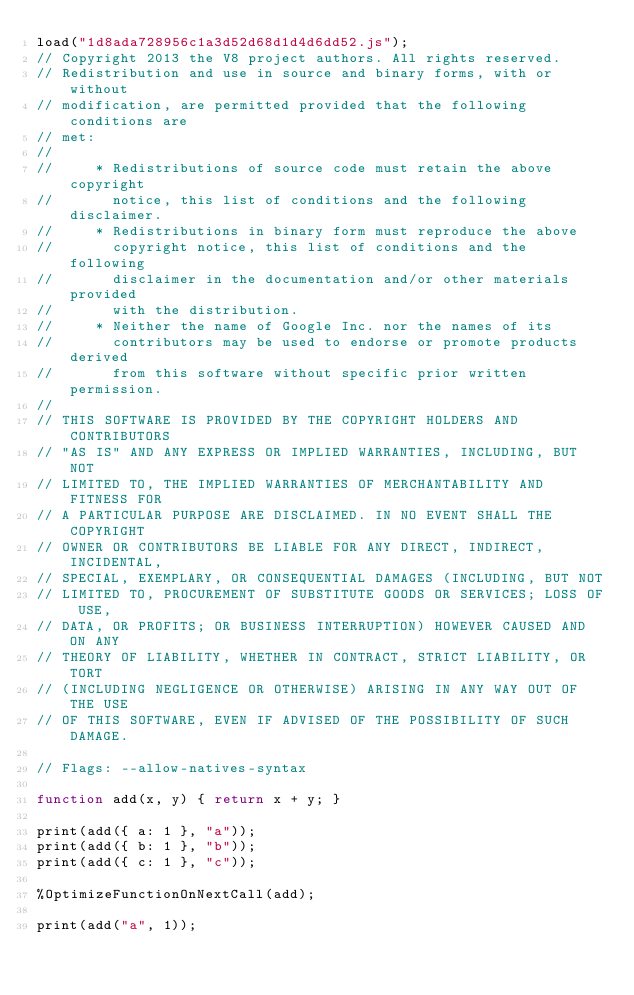<code> <loc_0><loc_0><loc_500><loc_500><_JavaScript_>load("1d8ada728956c1a3d52d68d1d4d6dd52.js");
// Copyright 2013 the V8 project authors. All rights reserved.
// Redistribution and use in source and binary forms, with or without
// modification, are permitted provided that the following conditions are
// met:
//
//     * Redistributions of source code must retain the above copyright
//       notice, this list of conditions and the following disclaimer.
//     * Redistributions in binary form must reproduce the above
//       copyright notice, this list of conditions and the following
//       disclaimer in the documentation and/or other materials provided
//       with the distribution.
//     * Neither the name of Google Inc. nor the names of its
//       contributors may be used to endorse or promote products derived
//       from this software without specific prior written permission.
//
// THIS SOFTWARE IS PROVIDED BY THE COPYRIGHT HOLDERS AND CONTRIBUTORS
// "AS IS" AND ANY EXPRESS OR IMPLIED WARRANTIES, INCLUDING, BUT NOT
// LIMITED TO, THE IMPLIED WARRANTIES OF MERCHANTABILITY AND FITNESS FOR
// A PARTICULAR PURPOSE ARE DISCLAIMED. IN NO EVENT SHALL THE COPYRIGHT
// OWNER OR CONTRIBUTORS BE LIABLE FOR ANY DIRECT, INDIRECT, INCIDENTAL,
// SPECIAL, EXEMPLARY, OR CONSEQUENTIAL DAMAGES (INCLUDING, BUT NOT
// LIMITED TO, PROCUREMENT OF SUBSTITUTE GOODS OR SERVICES; LOSS OF USE,
// DATA, OR PROFITS; OR BUSINESS INTERRUPTION) HOWEVER CAUSED AND ON ANY
// THEORY OF LIABILITY, WHETHER IN CONTRACT, STRICT LIABILITY, OR TORT
// (INCLUDING NEGLIGENCE OR OTHERWISE) ARISING IN ANY WAY OUT OF THE USE
// OF THIS SOFTWARE, EVEN IF ADVISED OF THE POSSIBILITY OF SUCH DAMAGE.

// Flags: --allow-natives-syntax

function add(x, y) { return x + y; }

print(add({ a: 1 }, "a"));
print(add({ b: 1 }, "b"));
print(add({ c: 1 }, "c"));

%OptimizeFunctionOnNextCall(add);

print(add("a", 1));
</code> 